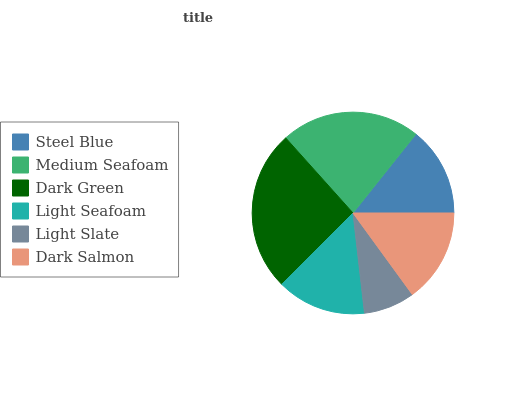Is Light Slate the minimum?
Answer yes or no. Yes. Is Dark Green the maximum?
Answer yes or no. Yes. Is Medium Seafoam the minimum?
Answer yes or no. No. Is Medium Seafoam the maximum?
Answer yes or no. No. Is Medium Seafoam greater than Steel Blue?
Answer yes or no. Yes. Is Steel Blue less than Medium Seafoam?
Answer yes or no. Yes. Is Steel Blue greater than Medium Seafoam?
Answer yes or no. No. Is Medium Seafoam less than Steel Blue?
Answer yes or no. No. Is Dark Salmon the high median?
Answer yes or no. Yes. Is Light Seafoam the low median?
Answer yes or no. Yes. Is Light Slate the high median?
Answer yes or no. No. Is Medium Seafoam the low median?
Answer yes or no. No. 